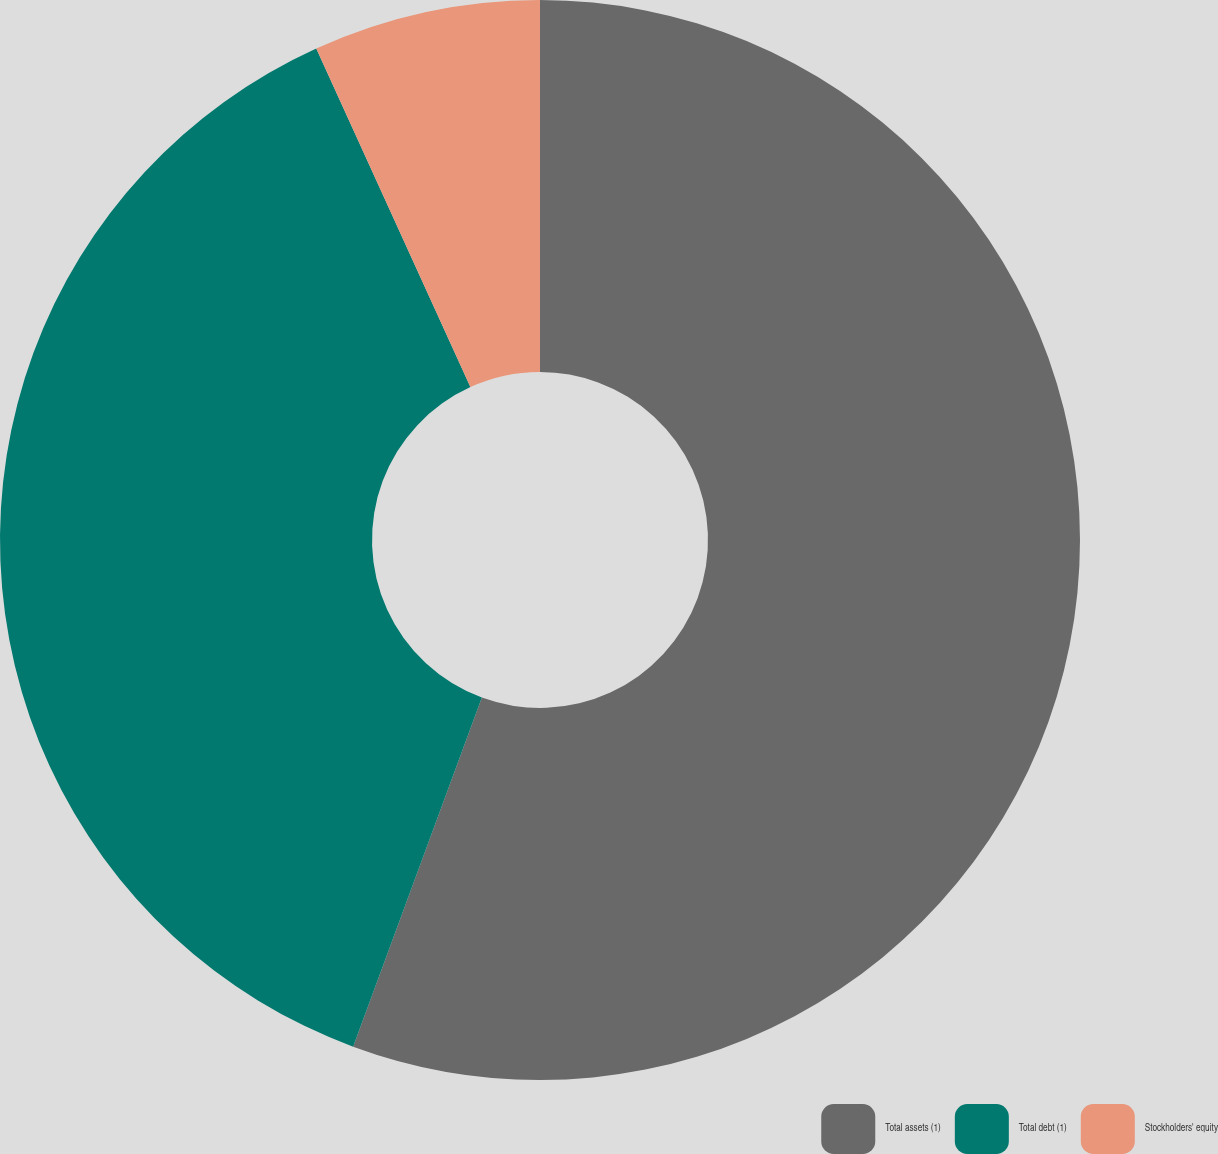<chart> <loc_0><loc_0><loc_500><loc_500><pie_chart><fcel>Total assets (1)<fcel>Total debt (1)<fcel>Stockholders' equity<nl><fcel>55.63%<fcel>37.58%<fcel>6.8%<nl></chart> 